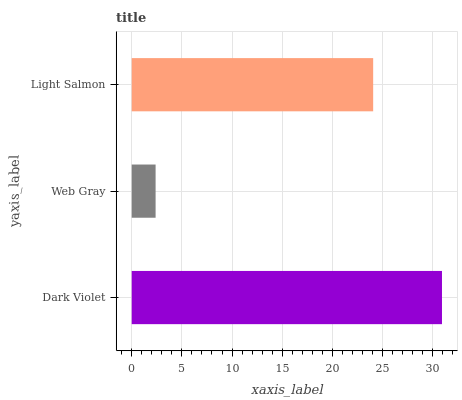Is Web Gray the minimum?
Answer yes or no. Yes. Is Dark Violet the maximum?
Answer yes or no. Yes. Is Light Salmon the minimum?
Answer yes or no. No. Is Light Salmon the maximum?
Answer yes or no. No. Is Light Salmon greater than Web Gray?
Answer yes or no. Yes. Is Web Gray less than Light Salmon?
Answer yes or no. Yes. Is Web Gray greater than Light Salmon?
Answer yes or no. No. Is Light Salmon less than Web Gray?
Answer yes or no. No. Is Light Salmon the high median?
Answer yes or no. Yes. Is Light Salmon the low median?
Answer yes or no. Yes. Is Dark Violet the high median?
Answer yes or no. No. Is Web Gray the low median?
Answer yes or no. No. 